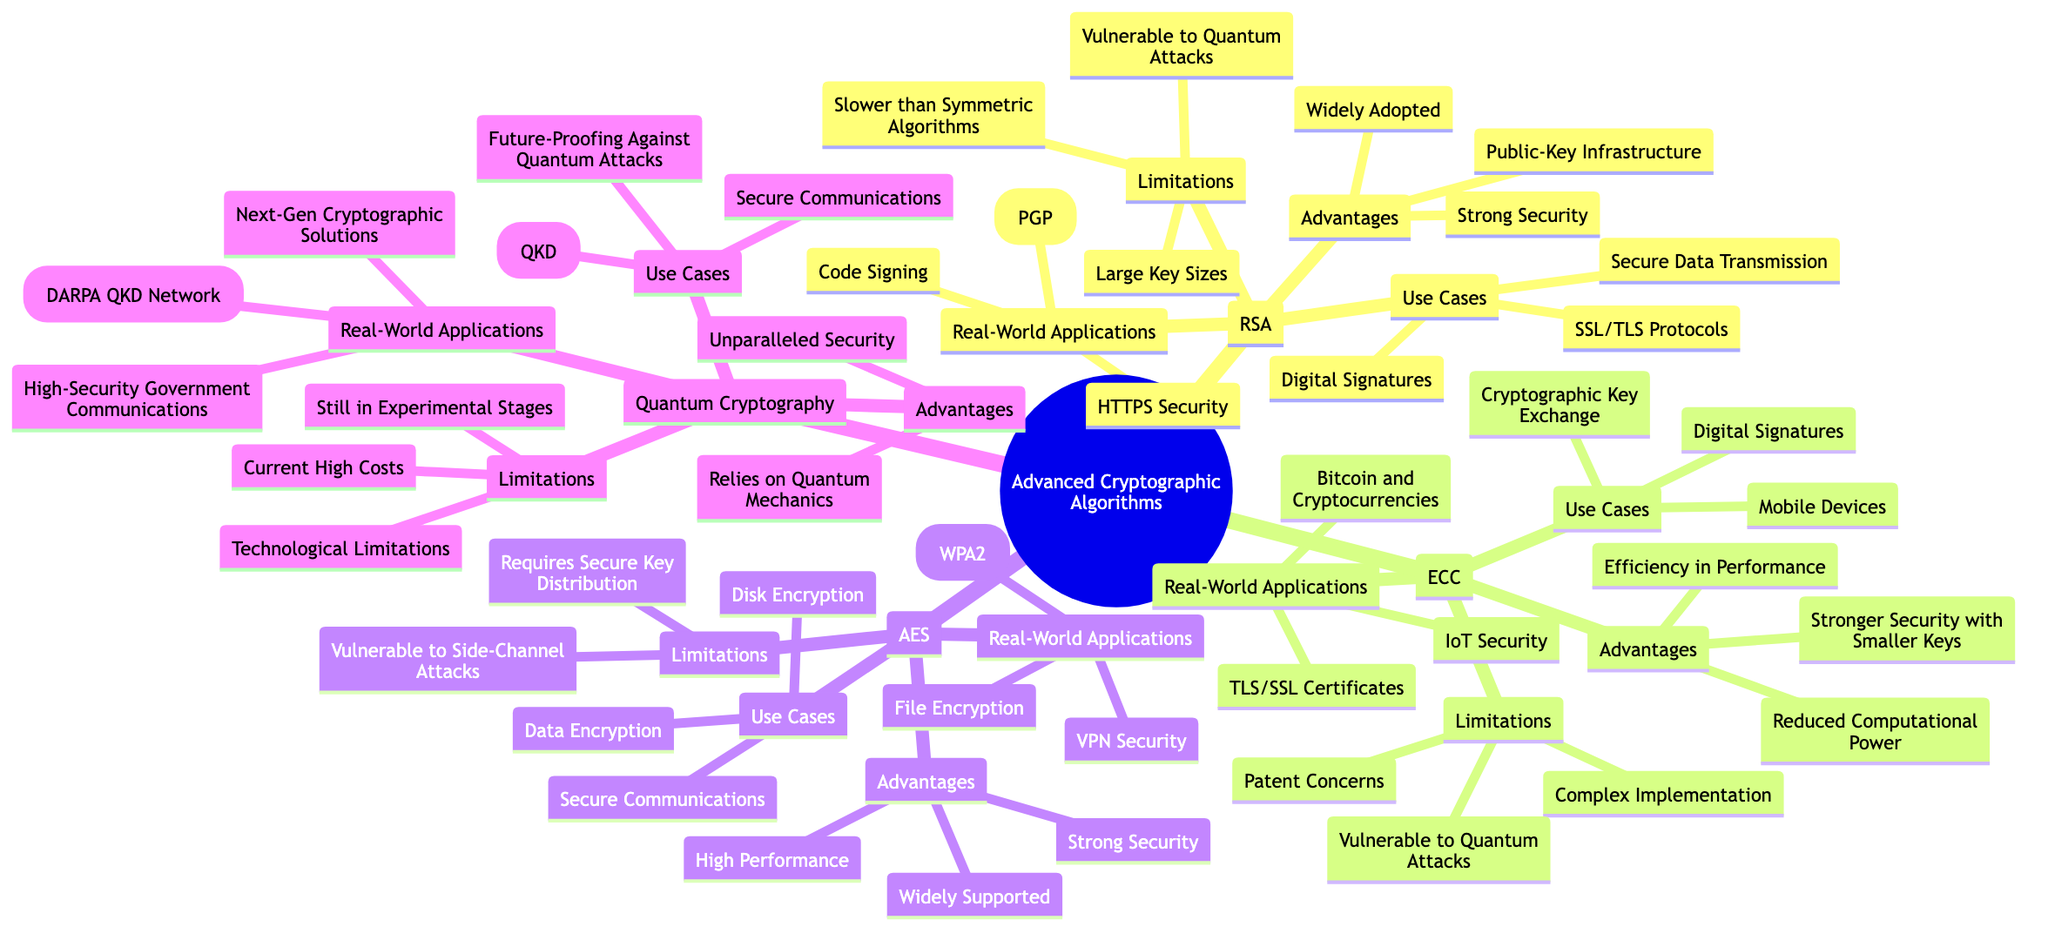What are the advantages of AES? The diagram lists three advantages for AES: High Performance, Strong Security, and Widely Supported.
Answer: High Performance, Strong Security, Widely Supported How many real-world applications does RSA have? The diagram shows a total of three applications listed under RSA's Real-World Applications: HTTPS Security, Email Encryption (PGP), and Code Signing.
Answer: 3 What is a limitation of Quantum Cryptography? Quantum Cryptography has three limitations shown in the diagram: Current High Costs, Technological and Infrastructure Limitations, and Still in Experimental Stages. Any one of these can be an answer.
Answer: Current High Costs Which cryptographic algorithm is commonly used in IoT security? The diagram indicates that ECC (Elliptic Curve Cryptography) has IoT Security listed under its Real-World Applications.
Answer: ECC What are two use cases for RSA? The diagram has three use cases listed for RSA: Secure Data Transmission, Digital Signatures, and SSL/TLS Protocols. Any two of these would be a valid answer.
Answer: Secure Data Transmission, Digital Signatures What type of cryptography relies on quantum mechanics? Quantum Cryptography is the only algorithm referenced in the diagram that emphasizes its reliance on quantum mechanics as an advantage.
Answer: Quantum Cryptography Which algorithm is recognized for mobile device security? The diagram associates ECC (Elliptic Curve Cryptography) with Mobile Devices in its Use Cases.
Answer: ECC What is the major advantage of ECC compared to RSA? The diagram highlights that ECC provides Stronger Security with Smaller Keys, making it more efficient compared to RSA's larger key sizes.
Answer: Stronger Security with Smaller Keys How many algorithms are discussed in the mind map? The mind map presents a total of four main cryptographic algorithms: RSA, ECC, AES, and Quantum Cryptography.
Answer: 4 